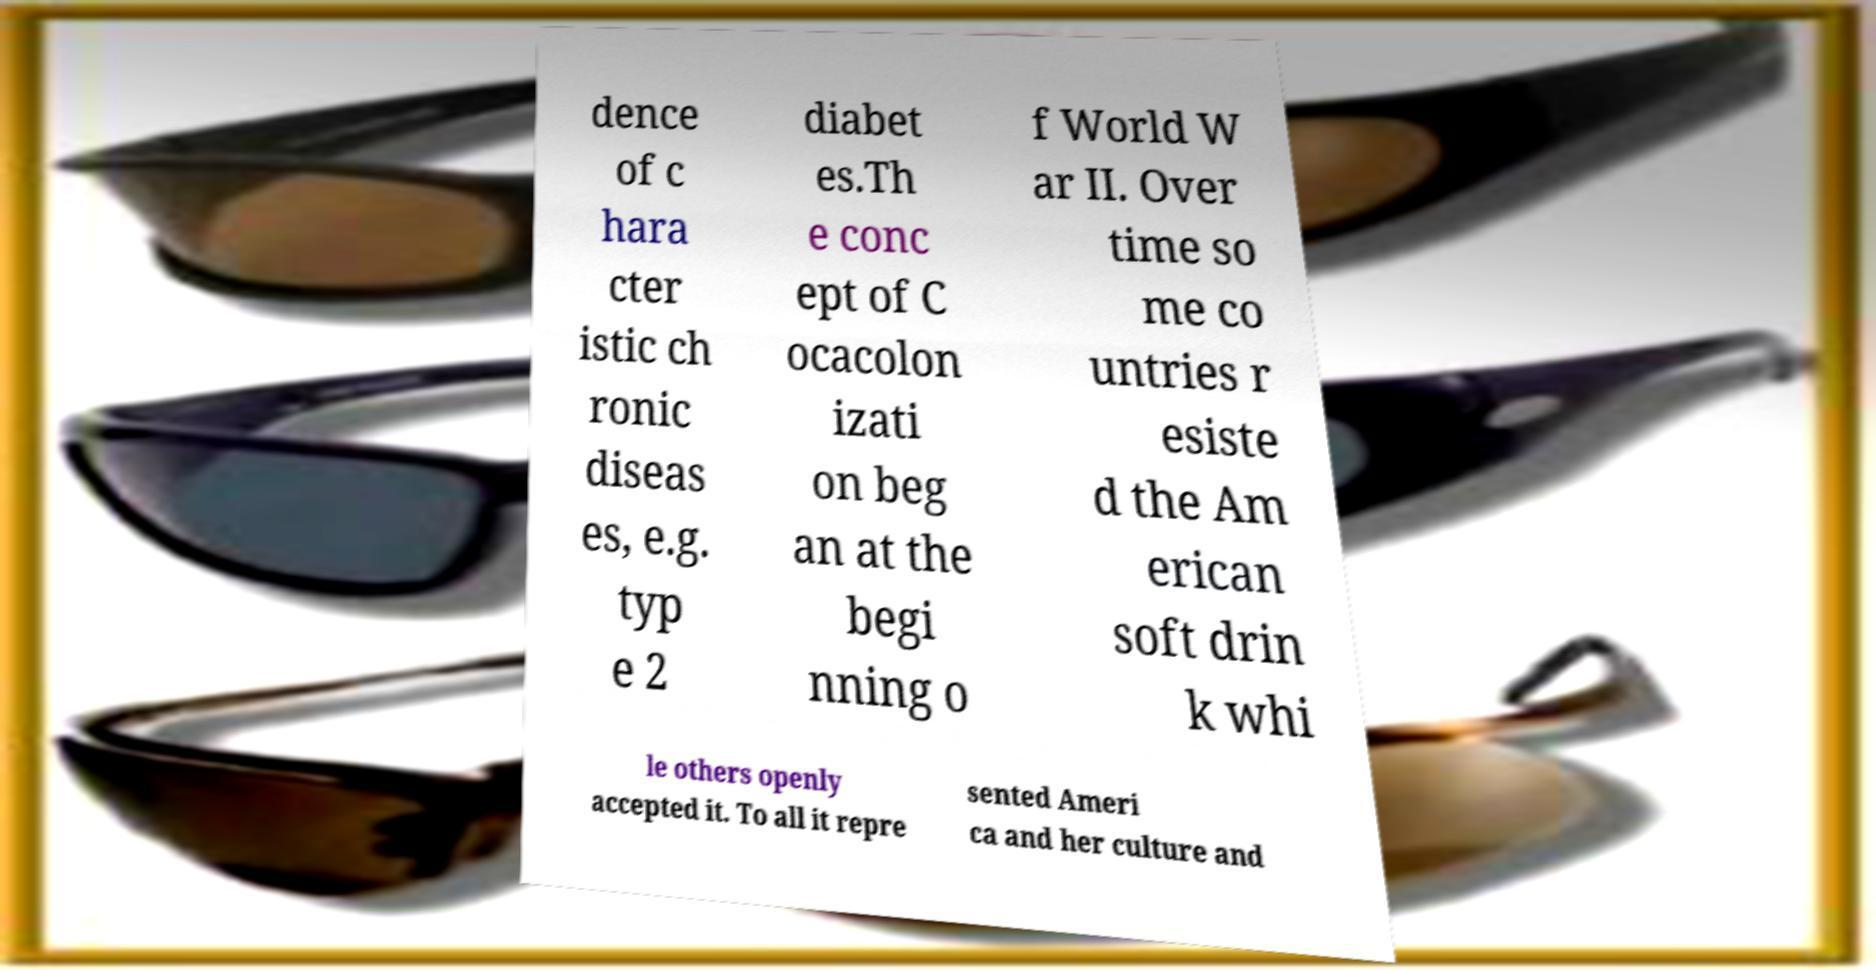Please identify and transcribe the text found in this image. dence of c hara cter istic ch ronic diseas es, e.g. typ e 2 diabet es.Th e conc ept of C ocacolon izati on beg an at the begi nning o f World W ar II. Over time so me co untries r esiste d the Am erican soft drin k whi le others openly accepted it. To all it repre sented Ameri ca and her culture and 